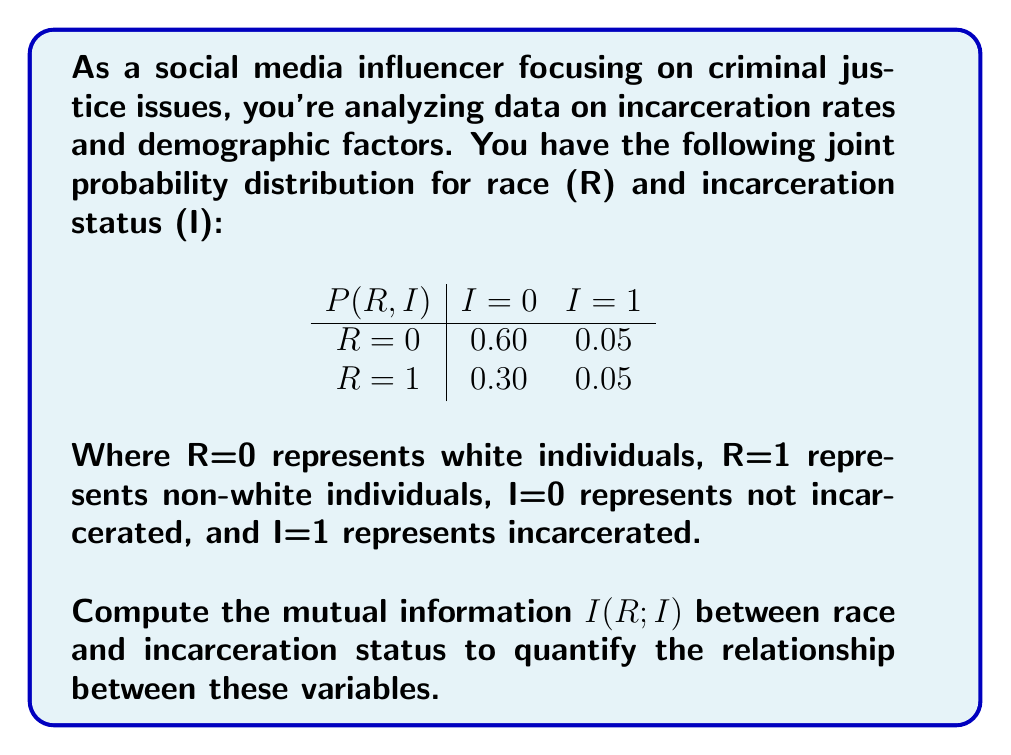Can you solve this math problem? To compute the mutual information $I(R;I)$, we'll follow these steps:

1) First, calculate the marginal probabilities:
   $P(R=0) = 0.60 + 0.05 = 0.65$
   $P(R=1) = 0.30 + 0.05 = 0.35$
   $P(I=0) = 0.60 + 0.30 = 0.90$
   $P(I=1) = 0.05 + 0.05 = 0.10$

2) The mutual information formula is:
   $$I(R;I) = \sum_{r}\sum_{i} P(r,i) \log_2 \frac{P(r,i)}{P(r)P(i)}$$

3) Calculate each term:
   For R=0, I=0: $0.60 \log_2 \frac{0.60}{0.65 \cdot 0.90} = 0.0220$
   For R=0, I=1: $0.05 \log_2 \frac{0.05}{0.65 \cdot 0.10} = 0.0140$
   For R=1, I=0: $0.30 \log_2 \frac{0.30}{0.35 \cdot 0.90} = -0.0396$
   For R=1, I=1: $0.05 \log_2 \frac{0.05}{0.35 \cdot 0.10} = 0.0513$

4) Sum all terms:
   $I(R;I) = 0.0220 + 0.0140 - 0.0396 + 0.0513 = 0.0477$

5) The mutual information is approximately 0.0477 bits.
Answer: $I(R;I) \approx 0.0477$ bits 